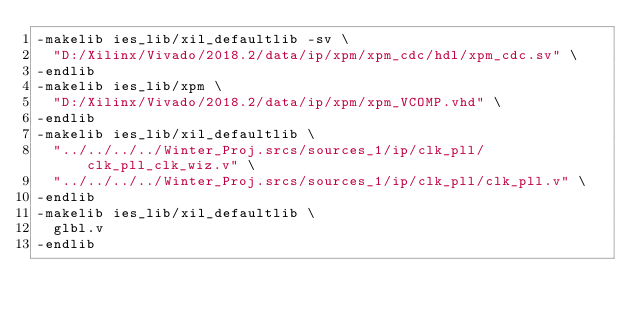<code> <loc_0><loc_0><loc_500><loc_500><_FORTRAN_>-makelib ies_lib/xil_defaultlib -sv \
  "D:/Xilinx/Vivado/2018.2/data/ip/xpm/xpm_cdc/hdl/xpm_cdc.sv" \
-endlib
-makelib ies_lib/xpm \
  "D:/Xilinx/Vivado/2018.2/data/ip/xpm/xpm_VCOMP.vhd" \
-endlib
-makelib ies_lib/xil_defaultlib \
  "../../../../Winter_Proj.srcs/sources_1/ip/clk_pll/clk_pll_clk_wiz.v" \
  "../../../../Winter_Proj.srcs/sources_1/ip/clk_pll/clk_pll.v" \
-endlib
-makelib ies_lib/xil_defaultlib \
  glbl.v
-endlib

</code> 